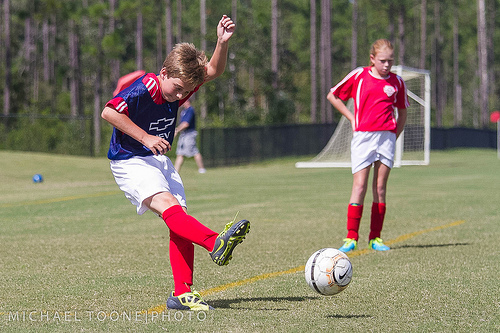<image>
Can you confirm if the sock is above the shoe? Yes. The sock is positioned above the shoe in the vertical space, higher up in the scene. 